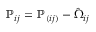Convert formula to latex. <formula><loc_0><loc_0><loc_500><loc_500>{ \mathbb { P } } _ { i j } = { \mathbb { P } } _ { ( i j ) } - \hat { \Omega } _ { i j }</formula> 